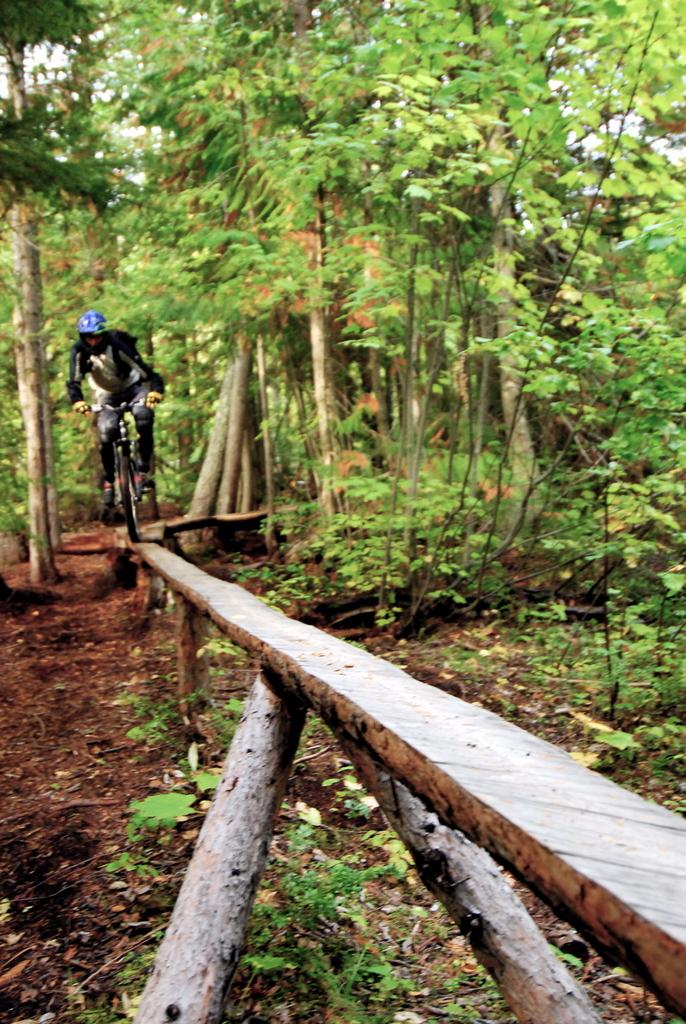What is the main subject of the image? The main subject of the image is a person riding a bicycle. What is the person riding the bicycle on? The person is riding the bicycle on a wooden object. What can be seen in the background of the image? There are trees and plants in the background of the image. What crime is the person on the bicycle committing in the image? There is no indication of a crime being committed in the image. Can you tell me the name of the person riding the bicycle in the image? The image does not provide any information about the person's name. 